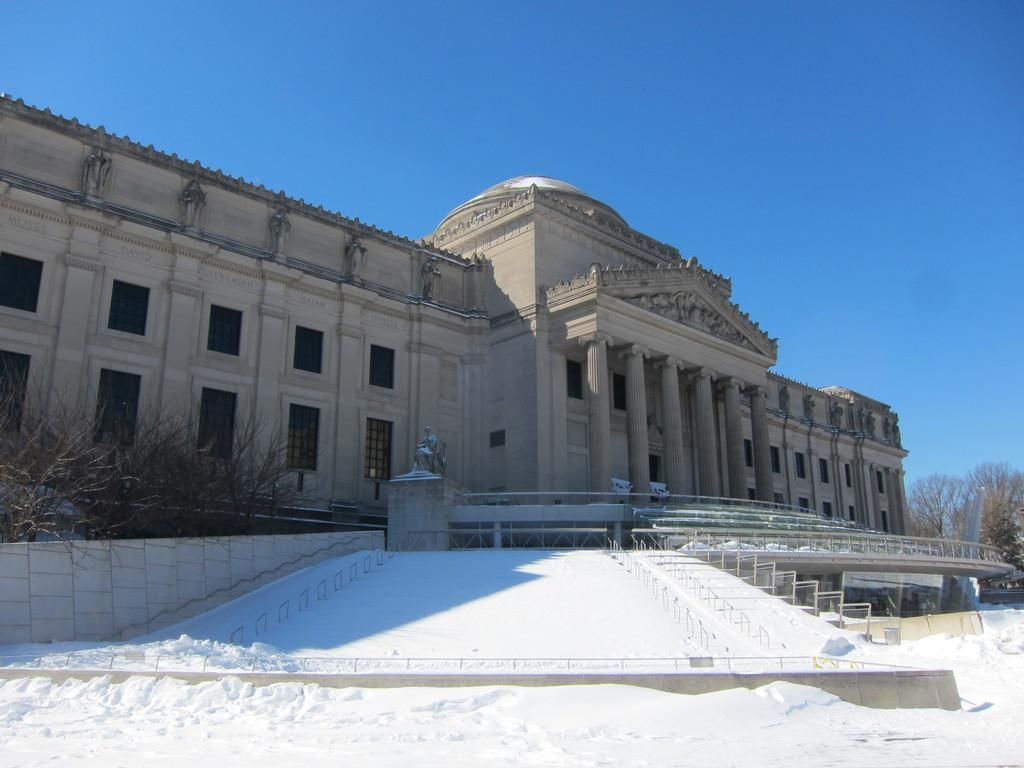What type of living organisms can be seen in the image? Plants can be seen in the image. What structure is visible in the background of the image? There is a building in the background of the image. What color is the building? The building is in a cream color. What is the color of the sky in the image? The sky is blue in the image. How many chickens are present in the image? There are no chickens present in the image. What type of basin can be seen in the image? There is no basin present in the image. 